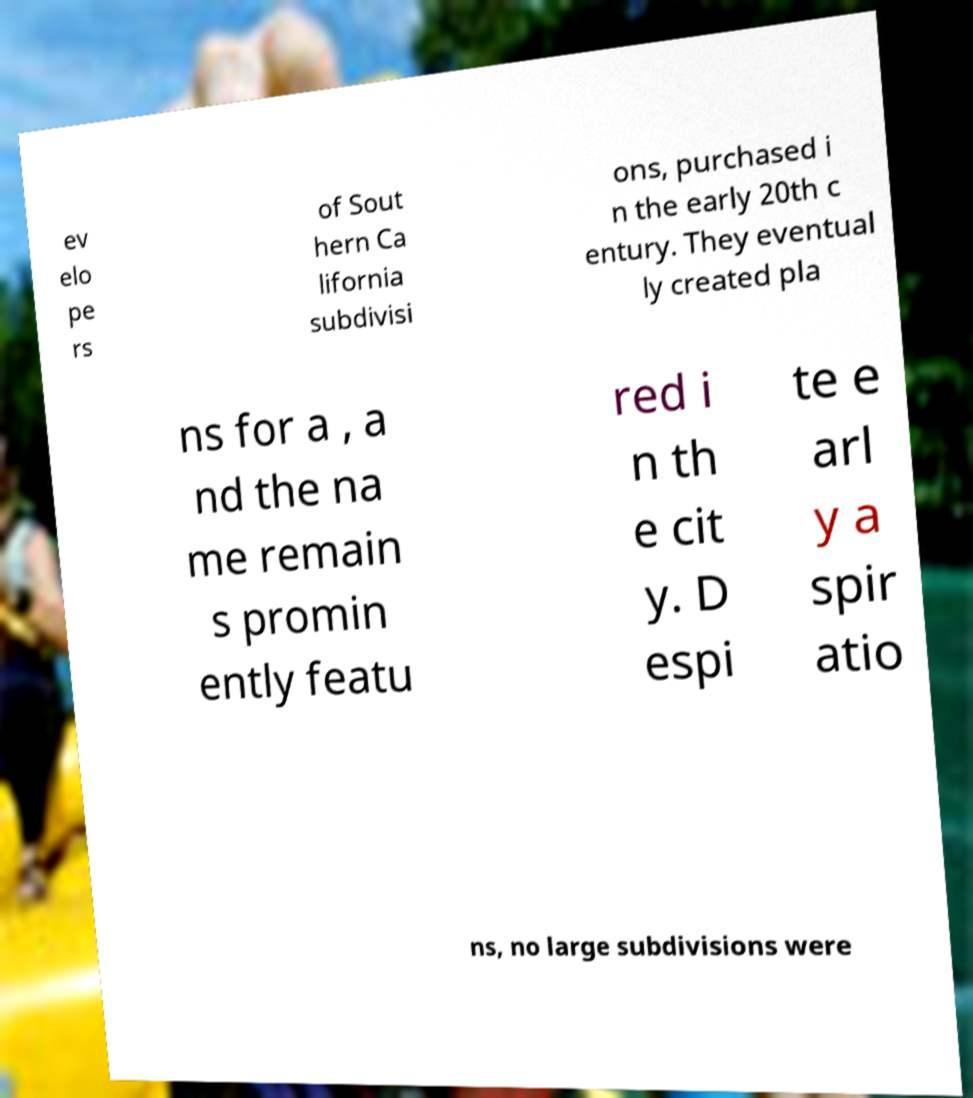What messages or text are displayed in this image? I need them in a readable, typed format. ev elo pe rs of Sout hern Ca lifornia subdivisi ons, purchased i n the early 20th c entury. They eventual ly created pla ns for a , a nd the na me remain s promin ently featu red i n th e cit y. D espi te e arl y a spir atio ns, no large subdivisions were 